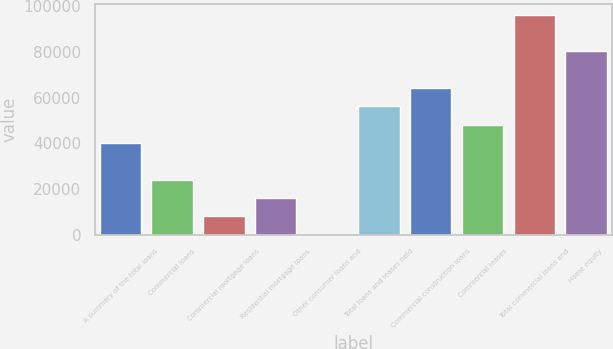<chart> <loc_0><loc_0><loc_500><loc_500><bar_chart><fcel>A summary of the total loans<fcel>Commercial loans<fcel>Commercial mortgage loans<fcel>Residential mortgage loans<fcel>Other consumer loans and<fcel>Total loans and leases held<fcel>Commercial construction loans<fcel>Commercial leases<fcel>Total commercial loans and<fcel>Home equity<nl><fcel>40168<fcel>24134<fcel>8100<fcel>16117<fcel>83<fcel>56202<fcel>64219<fcel>48185<fcel>96287<fcel>80253<nl></chart> 